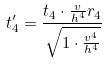Convert formula to latex. <formula><loc_0><loc_0><loc_500><loc_500>t _ { 4 } ^ { \prime } = \frac { t _ { 4 } \cdot \frac { v } { h ^ { 4 } } r _ { 4 } } { \sqrt { 1 \cdot \frac { v ^ { 4 } } { h ^ { 4 } } } }</formula> 